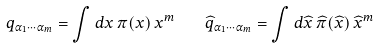<formula> <loc_0><loc_0><loc_500><loc_500>q _ { \alpha _ { 1 } \cdots \alpha _ { m } } = \int d x \, \pi ( x ) \, x ^ { m } \quad \widehat { q } _ { \alpha _ { 1 } \cdots \alpha _ { m } } = \int d \widehat { x } \, \widehat { \pi } ( \widehat { x } ) \, \widehat { x } ^ { m }</formula> 